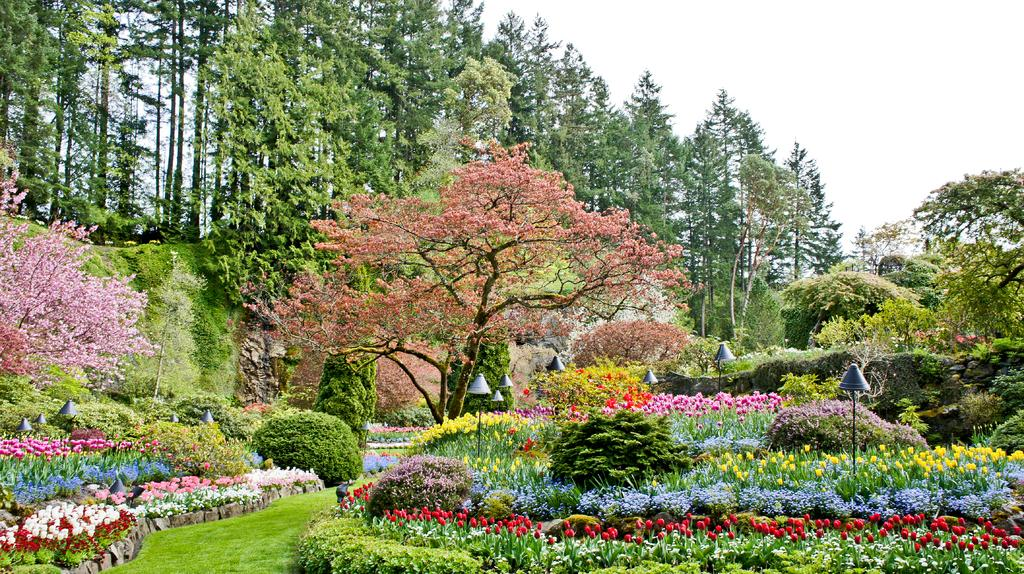What type of vegetation can be seen in the image? There are trees in the image. What else can be seen in the image besides trees? There are poles and different color flowers in the garden visible in the image. How is the sky depicted in the image? The sky is in white color in the image. Can you see any rabbits hopping in the garden in the image? There are no rabbits visible in the image; it only shows trees, poles, and different color flowers in the garden. What type of stamp is used to color the sky in the image? The sky in the image is depicted in white color, and there is no mention of any stamp being used to color it. 